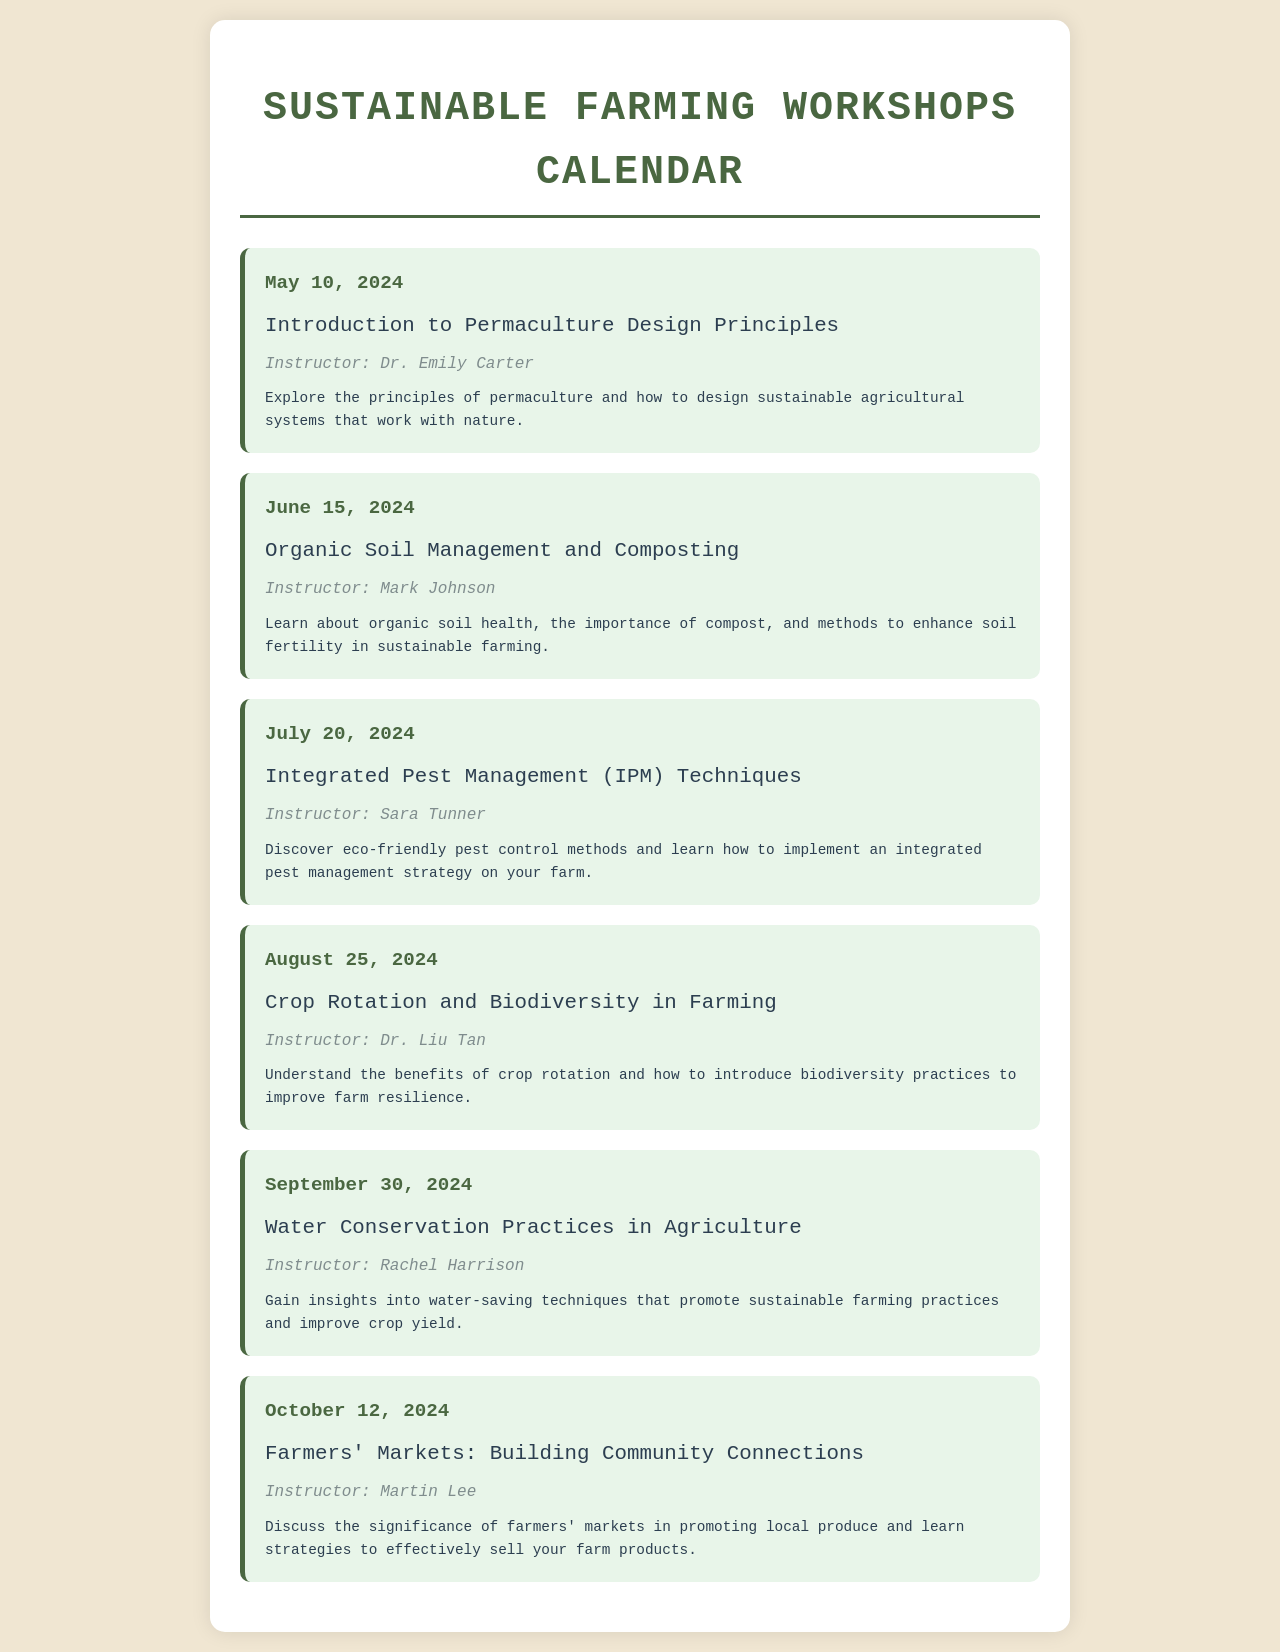What is the date of the first workshop? The date of the first workshop, titled "Introduction to Permaculture Design Principles," is May 10, 2024.
Answer: May 10, 2024 Who is the instructor for the organic soil management workshop? The workshop on "Organic Soil Management and Composting" has Mark Johnson as the instructor.
Answer: Mark Johnson What is the main topic of the workshop on July 20, 2024? The workshop scheduled for July 20, 2024, focuses on Integrated Pest Management (IPM) Techniques.
Answer: Integrated Pest Management (IPM) Techniques How many workshops are scheduled before October 2024? There are six workshops scheduled between May and October 2024; May 10, June 15, July 20, August 25, September 30, and October 12.
Answer: 6 What type of practices will be discussed on September 30, 2024? The workshop on September 30, 2024, will cover water conservation practices in agriculture.
Answer: Water conservation practices Who will lead the workshop on crop rotation? The workshop titled "Crop Rotation and Biodiversity in Farming" will be led by Dr. Liu Tan.
Answer: Dr. Liu Tan Which workshop emphasizes community connections? The workshop that emphasizes community connections is "Farmers' Markets: Building Community Connections."
Answer: Farmers' Markets: Building Community Connections What is the theme of the workshop on August 25, 2024? The theme of the workshop on August 25, 2024, is crop rotation and biodiversity in farming.
Answer: Crop rotation and biodiversity in farming 